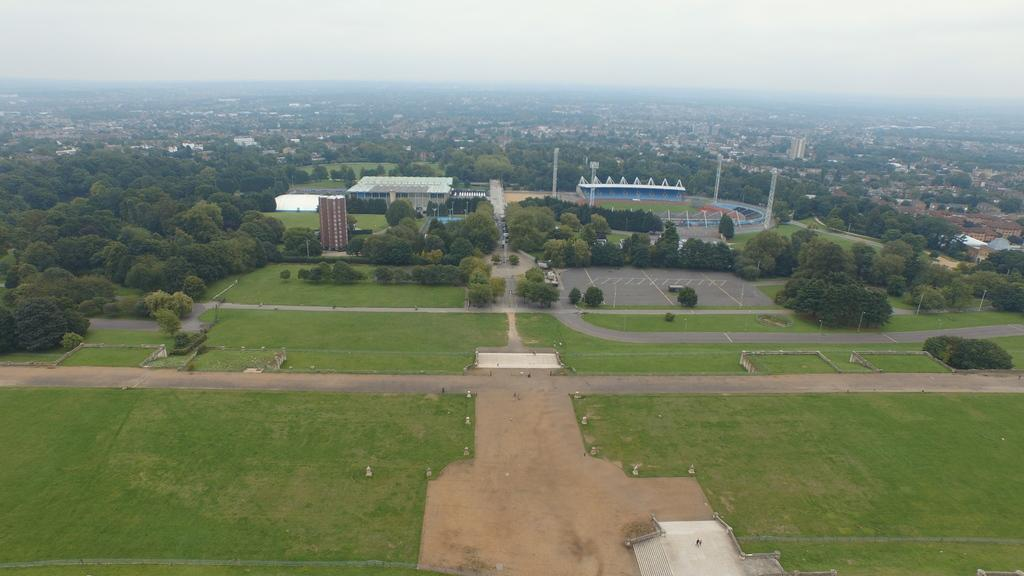What type of landscape is depicted in the image? The image shows a view of the city. What specific features can be seen in the cityscape? There are buildings, trees, grass, roads, and a pathway visible in the image. Can you describe the vegetation in the image? There are trees and grass present in the image. What type of transportation infrastructure is visible in the image? There are roads in the image. What type of polish is being applied to the trees in the image? There is no indication in the image that any polish is being applied to the trees; they appear to be natural. Can you tell me how many cats are walking on the pathway in the image? There are no cats present in the image; only trees, grass, roads, and a pathway are visible. 